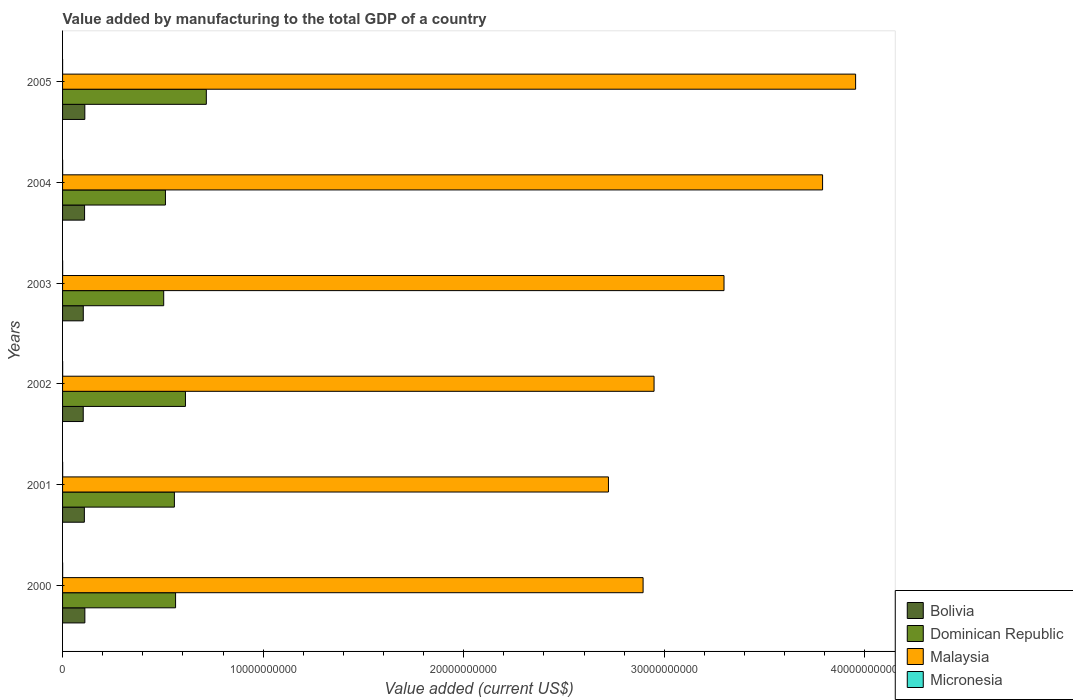How many different coloured bars are there?
Your answer should be compact. 4. Are the number of bars per tick equal to the number of legend labels?
Ensure brevity in your answer.  Yes. Are the number of bars on each tick of the Y-axis equal?
Offer a terse response. Yes. How many bars are there on the 6th tick from the top?
Your answer should be compact. 4. How many bars are there on the 1st tick from the bottom?
Your answer should be compact. 4. What is the value added by manufacturing to the total GDP in Micronesia in 2001?
Make the answer very short. 4.61e+06. Across all years, what is the maximum value added by manufacturing to the total GDP in Bolivia?
Provide a succinct answer. 1.11e+09. Across all years, what is the minimum value added by manufacturing to the total GDP in Bolivia?
Your answer should be compact. 1.03e+09. In which year was the value added by manufacturing to the total GDP in Micronesia maximum?
Provide a short and direct response. 2001. In which year was the value added by manufacturing to the total GDP in Bolivia minimum?
Provide a short and direct response. 2002. What is the total value added by manufacturing to the total GDP in Bolivia in the graph?
Your response must be concise. 6.47e+09. What is the difference between the value added by manufacturing to the total GDP in Malaysia in 2001 and that in 2002?
Offer a terse response. -2.27e+09. What is the difference between the value added by manufacturing to the total GDP in Bolivia in 2003 and the value added by manufacturing to the total GDP in Dominican Republic in 2002?
Your answer should be very brief. -5.09e+09. What is the average value added by manufacturing to the total GDP in Micronesia per year?
Offer a terse response. 3.63e+06. In the year 2003, what is the difference between the value added by manufacturing to the total GDP in Bolivia and value added by manufacturing to the total GDP in Dominican Republic?
Make the answer very short. -4.01e+09. In how many years, is the value added by manufacturing to the total GDP in Micronesia greater than 22000000000 US$?
Keep it short and to the point. 0. What is the ratio of the value added by manufacturing to the total GDP in Dominican Republic in 2002 to that in 2003?
Ensure brevity in your answer.  1.22. Is the difference between the value added by manufacturing to the total GDP in Bolivia in 2000 and 2004 greater than the difference between the value added by manufacturing to the total GDP in Dominican Republic in 2000 and 2004?
Your answer should be compact. No. What is the difference between the highest and the second highest value added by manufacturing to the total GDP in Micronesia?
Your response must be concise. 2.03e+05. What is the difference between the highest and the lowest value added by manufacturing to the total GDP in Dominican Republic?
Your answer should be compact. 2.13e+09. Is the sum of the value added by manufacturing to the total GDP in Bolivia in 2003 and 2005 greater than the maximum value added by manufacturing to the total GDP in Micronesia across all years?
Provide a short and direct response. Yes. What does the 1st bar from the top in 2002 represents?
Your response must be concise. Micronesia. What does the 2nd bar from the bottom in 2004 represents?
Ensure brevity in your answer.  Dominican Republic. Is it the case that in every year, the sum of the value added by manufacturing to the total GDP in Bolivia and value added by manufacturing to the total GDP in Micronesia is greater than the value added by manufacturing to the total GDP in Malaysia?
Ensure brevity in your answer.  No. How many bars are there?
Provide a succinct answer. 24. Are all the bars in the graph horizontal?
Offer a terse response. Yes. Are the values on the major ticks of X-axis written in scientific E-notation?
Ensure brevity in your answer.  No. Where does the legend appear in the graph?
Your answer should be compact. Bottom right. How many legend labels are there?
Make the answer very short. 4. What is the title of the graph?
Provide a succinct answer. Value added by manufacturing to the total GDP of a country. Does "Andorra" appear as one of the legend labels in the graph?
Provide a succinct answer. No. What is the label or title of the X-axis?
Give a very brief answer. Value added (current US$). What is the Value added (current US$) of Bolivia in 2000?
Provide a short and direct response. 1.11e+09. What is the Value added (current US$) in Dominican Republic in 2000?
Your answer should be very brief. 5.63e+09. What is the Value added (current US$) of Malaysia in 2000?
Your answer should be compact. 2.89e+1. What is the Value added (current US$) of Micronesia in 2000?
Your answer should be compact. 3.88e+06. What is the Value added (current US$) of Bolivia in 2001?
Make the answer very short. 1.09e+09. What is the Value added (current US$) in Dominican Republic in 2001?
Your response must be concise. 5.58e+09. What is the Value added (current US$) of Malaysia in 2001?
Offer a terse response. 2.72e+1. What is the Value added (current US$) in Micronesia in 2001?
Make the answer very short. 4.61e+06. What is the Value added (current US$) of Bolivia in 2002?
Give a very brief answer. 1.03e+09. What is the Value added (current US$) in Dominican Republic in 2002?
Offer a terse response. 6.13e+09. What is the Value added (current US$) in Malaysia in 2002?
Your answer should be very brief. 2.95e+1. What is the Value added (current US$) in Micronesia in 2002?
Your response must be concise. 4.41e+06. What is the Value added (current US$) of Bolivia in 2003?
Make the answer very short. 1.03e+09. What is the Value added (current US$) in Dominican Republic in 2003?
Offer a terse response. 5.04e+09. What is the Value added (current US$) of Malaysia in 2003?
Give a very brief answer. 3.30e+1. What is the Value added (current US$) of Micronesia in 2003?
Offer a terse response. 4.08e+06. What is the Value added (current US$) of Bolivia in 2004?
Offer a terse response. 1.10e+09. What is the Value added (current US$) of Dominican Republic in 2004?
Your response must be concise. 5.13e+09. What is the Value added (current US$) of Malaysia in 2004?
Provide a short and direct response. 3.79e+1. What is the Value added (current US$) in Micronesia in 2004?
Your answer should be compact. 3.40e+06. What is the Value added (current US$) in Bolivia in 2005?
Give a very brief answer. 1.11e+09. What is the Value added (current US$) of Dominican Republic in 2005?
Offer a very short reply. 7.17e+09. What is the Value added (current US$) in Malaysia in 2005?
Your answer should be very brief. 3.95e+1. What is the Value added (current US$) of Micronesia in 2005?
Provide a short and direct response. 1.40e+06. Across all years, what is the maximum Value added (current US$) of Bolivia?
Offer a terse response. 1.11e+09. Across all years, what is the maximum Value added (current US$) of Dominican Republic?
Provide a short and direct response. 7.17e+09. Across all years, what is the maximum Value added (current US$) of Malaysia?
Provide a succinct answer. 3.95e+1. Across all years, what is the maximum Value added (current US$) in Micronesia?
Make the answer very short. 4.61e+06. Across all years, what is the minimum Value added (current US$) in Bolivia?
Your response must be concise. 1.03e+09. Across all years, what is the minimum Value added (current US$) in Dominican Republic?
Offer a terse response. 5.04e+09. Across all years, what is the minimum Value added (current US$) of Malaysia?
Offer a terse response. 2.72e+1. Across all years, what is the minimum Value added (current US$) in Micronesia?
Make the answer very short. 1.40e+06. What is the total Value added (current US$) of Bolivia in the graph?
Offer a terse response. 6.47e+09. What is the total Value added (current US$) in Dominican Republic in the graph?
Your answer should be compact. 3.47e+1. What is the total Value added (current US$) in Malaysia in the graph?
Your answer should be compact. 1.96e+11. What is the total Value added (current US$) in Micronesia in the graph?
Provide a short and direct response. 2.18e+07. What is the difference between the Value added (current US$) of Bolivia in 2000 and that in 2001?
Offer a terse response. 2.55e+07. What is the difference between the Value added (current US$) of Dominican Republic in 2000 and that in 2001?
Provide a short and direct response. 5.89e+07. What is the difference between the Value added (current US$) in Malaysia in 2000 and that in 2001?
Offer a very short reply. 1.73e+09. What is the difference between the Value added (current US$) in Micronesia in 2000 and that in 2001?
Your response must be concise. -7.32e+05. What is the difference between the Value added (current US$) in Bolivia in 2000 and that in 2002?
Your answer should be very brief. 8.15e+07. What is the difference between the Value added (current US$) of Dominican Republic in 2000 and that in 2002?
Your response must be concise. -4.93e+08. What is the difference between the Value added (current US$) in Malaysia in 2000 and that in 2002?
Offer a very short reply. -5.47e+08. What is the difference between the Value added (current US$) in Micronesia in 2000 and that in 2002?
Offer a very short reply. -5.28e+05. What is the difference between the Value added (current US$) in Bolivia in 2000 and that in 2003?
Make the answer very short. 7.87e+07. What is the difference between the Value added (current US$) of Dominican Republic in 2000 and that in 2003?
Provide a short and direct response. 5.92e+08. What is the difference between the Value added (current US$) in Malaysia in 2000 and that in 2003?
Give a very brief answer. -4.04e+09. What is the difference between the Value added (current US$) in Micronesia in 2000 and that in 2003?
Offer a very short reply. -2.00e+05. What is the difference between the Value added (current US$) of Bolivia in 2000 and that in 2004?
Offer a very short reply. 1.46e+07. What is the difference between the Value added (current US$) of Dominican Republic in 2000 and that in 2004?
Ensure brevity in your answer.  5.06e+08. What is the difference between the Value added (current US$) of Malaysia in 2000 and that in 2004?
Your response must be concise. -8.95e+09. What is the difference between the Value added (current US$) of Micronesia in 2000 and that in 2004?
Offer a terse response. 4.79e+05. What is the difference between the Value added (current US$) in Bolivia in 2000 and that in 2005?
Ensure brevity in your answer.  1.71e+06. What is the difference between the Value added (current US$) of Dominican Republic in 2000 and that in 2005?
Your response must be concise. -1.53e+09. What is the difference between the Value added (current US$) of Malaysia in 2000 and that in 2005?
Your answer should be compact. -1.06e+1. What is the difference between the Value added (current US$) of Micronesia in 2000 and that in 2005?
Keep it short and to the point. 2.48e+06. What is the difference between the Value added (current US$) in Bolivia in 2001 and that in 2002?
Your response must be concise. 5.60e+07. What is the difference between the Value added (current US$) of Dominican Republic in 2001 and that in 2002?
Keep it short and to the point. -5.52e+08. What is the difference between the Value added (current US$) of Malaysia in 2001 and that in 2002?
Keep it short and to the point. -2.27e+09. What is the difference between the Value added (current US$) in Micronesia in 2001 and that in 2002?
Ensure brevity in your answer.  2.03e+05. What is the difference between the Value added (current US$) in Bolivia in 2001 and that in 2003?
Give a very brief answer. 5.32e+07. What is the difference between the Value added (current US$) in Dominican Republic in 2001 and that in 2003?
Provide a short and direct response. 5.33e+08. What is the difference between the Value added (current US$) of Malaysia in 2001 and that in 2003?
Give a very brief answer. -5.76e+09. What is the difference between the Value added (current US$) in Micronesia in 2001 and that in 2003?
Your answer should be compact. 5.32e+05. What is the difference between the Value added (current US$) in Bolivia in 2001 and that in 2004?
Give a very brief answer. -1.09e+07. What is the difference between the Value added (current US$) of Dominican Republic in 2001 and that in 2004?
Your answer should be compact. 4.47e+08. What is the difference between the Value added (current US$) of Malaysia in 2001 and that in 2004?
Offer a terse response. -1.07e+1. What is the difference between the Value added (current US$) in Micronesia in 2001 and that in 2004?
Your answer should be very brief. 1.21e+06. What is the difference between the Value added (current US$) of Bolivia in 2001 and that in 2005?
Your response must be concise. -2.38e+07. What is the difference between the Value added (current US$) in Dominican Republic in 2001 and that in 2005?
Provide a succinct answer. -1.59e+09. What is the difference between the Value added (current US$) in Malaysia in 2001 and that in 2005?
Provide a short and direct response. -1.23e+1. What is the difference between the Value added (current US$) of Micronesia in 2001 and that in 2005?
Make the answer very short. 3.21e+06. What is the difference between the Value added (current US$) of Bolivia in 2002 and that in 2003?
Your response must be concise. -2.77e+06. What is the difference between the Value added (current US$) in Dominican Republic in 2002 and that in 2003?
Provide a succinct answer. 1.08e+09. What is the difference between the Value added (current US$) of Malaysia in 2002 and that in 2003?
Provide a succinct answer. -3.49e+09. What is the difference between the Value added (current US$) in Micronesia in 2002 and that in 2003?
Your answer should be very brief. 3.28e+05. What is the difference between the Value added (current US$) of Bolivia in 2002 and that in 2004?
Provide a short and direct response. -6.68e+07. What is the difference between the Value added (current US$) of Dominican Republic in 2002 and that in 2004?
Give a very brief answer. 9.99e+08. What is the difference between the Value added (current US$) of Malaysia in 2002 and that in 2004?
Offer a very short reply. -8.40e+09. What is the difference between the Value added (current US$) in Micronesia in 2002 and that in 2004?
Offer a very short reply. 1.01e+06. What is the difference between the Value added (current US$) of Bolivia in 2002 and that in 2005?
Give a very brief answer. -7.98e+07. What is the difference between the Value added (current US$) in Dominican Republic in 2002 and that in 2005?
Provide a short and direct response. -1.04e+09. What is the difference between the Value added (current US$) of Malaysia in 2002 and that in 2005?
Your response must be concise. -1.00e+1. What is the difference between the Value added (current US$) of Micronesia in 2002 and that in 2005?
Provide a short and direct response. 3.01e+06. What is the difference between the Value added (current US$) of Bolivia in 2003 and that in 2004?
Your response must be concise. -6.40e+07. What is the difference between the Value added (current US$) in Dominican Republic in 2003 and that in 2004?
Offer a very short reply. -8.61e+07. What is the difference between the Value added (current US$) of Malaysia in 2003 and that in 2004?
Make the answer very short. -4.91e+09. What is the difference between the Value added (current US$) of Micronesia in 2003 and that in 2004?
Offer a terse response. 6.79e+05. What is the difference between the Value added (current US$) in Bolivia in 2003 and that in 2005?
Ensure brevity in your answer.  -7.70e+07. What is the difference between the Value added (current US$) of Dominican Republic in 2003 and that in 2005?
Keep it short and to the point. -2.13e+09. What is the difference between the Value added (current US$) in Malaysia in 2003 and that in 2005?
Ensure brevity in your answer.  -6.56e+09. What is the difference between the Value added (current US$) in Micronesia in 2003 and that in 2005?
Ensure brevity in your answer.  2.68e+06. What is the difference between the Value added (current US$) of Bolivia in 2004 and that in 2005?
Provide a succinct answer. -1.29e+07. What is the difference between the Value added (current US$) in Dominican Republic in 2004 and that in 2005?
Your response must be concise. -2.04e+09. What is the difference between the Value added (current US$) in Malaysia in 2004 and that in 2005?
Make the answer very short. -1.65e+09. What is the difference between the Value added (current US$) of Bolivia in 2000 and the Value added (current US$) of Dominican Republic in 2001?
Offer a very short reply. -4.46e+09. What is the difference between the Value added (current US$) in Bolivia in 2000 and the Value added (current US$) in Malaysia in 2001?
Ensure brevity in your answer.  -2.61e+1. What is the difference between the Value added (current US$) of Bolivia in 2000 and the Value added (current US$) of Micronesia in 2001?
Your response must be concise. 1.11e+09. What is the difference between the Value added (current US$) in Dominican Republic in 2000 and the Value added (current US$) in Malaysia in 2001?
Provide a short and direct response. -2.16e+1. What is the difference between the Value added (current US$) of Dominican Republic in 2000 and the Value added (current US$) of Micronesia in 2001?
Offer a terse response. 5.63e+09. What is the difference between the Value added (current US$) of Malaysia in 2000 and the Value added (current US$) of Micronesia in 2001?
Offer a terse response. 2.89e+1. What is the difference between the Value added (current US$) in Bolivia in 2000 and the Value added (current US$) in Dominican Republic in 2002?
Make the answer very short. -5.02e+09. What is the difference between the Value added (current US$) in Bolivia in 2000 and the Value added (current US$) in Malaysia in 2002?
Your answer should be compact. -2.84e+1. What is the difference between the Value added (current US$) in Bolivia in 2000 and the Value added (current US$) in Micronesia in 2002?
Offer a terse response. 1.11e+09. What is the difference between the Value added (current US$) of Dominican Republic in 2000 and the Value added (current US$) of Malaysia in 2002?
Your answer should be very brief. -2.39e+1. What is the difference between the Value added (current US$) in Dominican Republic in 2000 and the Value added (current US$) in Micronesia in 2002?
Make the answer very short. 5.63e+09. What is the difference between the Value added (current US$) in Malaysia in 2000 and the Value added (current US$) in Micronesia in 2002?
Provide a succinct answer. 2.89e+1. What is the difference between the Value added (current US$) of Bolivia in 2000 and the Value added (current US$) of Dominican Republic in 2003?
Offer a very short reply. -3.93e+09. What is the difference between the Value added (current US$) of Bolivia in 2000 and the Value added (current US$) of Malaysia in 2003?
Your answer should be compact. -3.19e+1. What is the difference between the Value added (current US$) of Bolivia in 2000 and the Value added (current US$) of Micronesia in 2003?
Your response must be concise. 1.11e+09. What is the difference between the Value added (current US$) in Dominican Republic in 2000 and the Value added (current US$) in Malaysia in 2003?
Keep it short and to the point. -2.73e+1. What is the difference between the Value added (current US$) in Dominican Republic in 2000 and the Value added (current US$) in Micronesia in 2003?
Provide a succinct answer. 5.63e+09. What is the difference between the Value added (current US$) in Malaysia in 2000 and the Value added (current US$) in Micronesia in 2003?
Keep it short and to the point. 2.89e+1. What is the difference between the Value added (current US$) of Bolivia in 2000 and the Value added (current US$) of Dominican Republic in 2004?
Offer a terse response. -4.02e+09. What is the difference between the Value added (current US$) in Bolivia in 2000 and the Value added (current US$) in Malaysia in 2004?
Provide a succinct answer. -3.68e+1. What is the difference between the Value added (current US$) of Bolivia in 2000 and the Value added (current US$) of Micronesia in 2004?
Provide a short and direct response. 1.11e+09. What is the difference between the Value added (current US$) in Dominican Republic in 2000 and the Value added (current US$) in Malaysia in 2004?
Ensure brevity in your answer.  -3.23e+1. What is the difference between the Value added (current US$) of Dominican Republic in 2000 and the Value added (current US$) of Micronesia in 2004?
Ensure brevity in your answer.  5.63e+09. What is the difference between the Value added (current US$) of Malaysia in 2000 and the Value added (current US$) of Micronesia in 2004?
Keep it short and to the point. 2.89e+1. What is the difference between the Value added (current US$) of Bolivia in 2000 and the Value added (current US$) of Dominican Republic in 2005?
Ensure brevity in your answer.  -6.06e+09. What is the difference between the Value added (current US$) in Bolivia in 2000 and the Value added (current US$) in Malaysia in 2005?
Give a very brief answer. -3.84e+1. What is the difference between the Value added (current US$) of Bolivia in 2000 and the Value added (current US$) of Micronesia in 2005?
Your response must be concise. 1.11e+09. What is the difference between the Value added (current US$) in Dominican Republic in 2000 and the Value added (current US$) in Malaysia in 2005?
Keep it short and to the point. -3.39e+1. What is the difference between the Value added (current US$) in Dominican Republic in 2000 and the Value added (current US$) in Micronesia in 2005?
Offer a terse response. 5.63e+09. What is the difference between the Value added (current US$) in Malaysia in 2000 and the Value added (current US$) in Micronesia in 2005?
Give a very brief answer. 2.89e+1. What is the difference between the Value added (current US$) in Bolivia in 2001 and the Value added (current US$) in Dominican Republic in 2002?
Offer a terse response. -5.04e+09. What is the difference between the Value added (current US$) in Bolivia in 2001 and the Value added (current US$) in Malaysia in 2002?
Keep it short and to the point. -2.84e+1. What is the difference between the Value added (current US$) of Bolivia in 2001 and the Value added (current US$) of Micronesia in 2002?
Provide a succinct answer. 1.08e+09. What is the difference between the Value added (current US$) in Dominican Republic in 2001 and the Value added (current US$) in Malaysia in 2002?
Offer a very short reply. -2.39e+1. What is the difference between the Value added (current US$) of Dominican Republic in 2001 and the Value added (current US$) of Micronesia in 2002?
Provide a short and direct response. 5.57e+09. What is the difference between the Value added (current US$) in Malaysia in 2001 and the Value added (current US$) in Micronesia in 2002?
Provide a succinct answer. 2.72e+1. What is the difference between the Value added (current US$) in Bolivia in 2001 and the Value added (current US$) in Dominican Republic in 2003?
Offer a terse response. -3.96e+09. What is the difference between the Value added (current US$) of Bolivia in 2001 and the Value added (current US$) of Malaysia in 2003?
Make the answer very short. -3.19e+1. What is the difference between the Value added (current US$) of Bolivia in 2001 and the Value added (current US$) of Micronesia in 2003?
Provide a short and direct response. 1.08e+09. What is the difference between the Value added (current US$) in Dominican Republic in 2001 and the Value added (current US$) in Malaysia in 2003?
Ensure brevity in your answer.  -2.74e+1. What is the difference between the Value added (current US$) of Dominican Republic in 2001 and the Value added (current US$) of Micronesia in 2003?
Provide a short and direct response. 5.57e+09. What is the difference between the Value added (current US$) in Malaysia in 2001 and the Value added (current US$) in Micronesia in 2003?
Provide a succinct answer. 2.72e+1. What is the difference between the Value added (current US$) of Bolivia in 2001 and the Value added (current US$) of Dominican Republic in 2004?
Offer a very short reply. -4.04e+09. What is the difference between the Value added (current US$) of Bolivia in 2001 and the Value added (current US$) of Malaysia in 2004?
Give a very brief answer. -3.68e+1. What is the difference between the Value added (current US$) of Bolivia in 2001 and the Value added (current US$) of Micronesia in 2004?
Offer a terse response. 1.08e+09. What is the difference between the Value added (current US$) in Dominican Republic in 2001 and the Value added (current US$) in Malaysia in 2004?
Your answer should be compact. -3.23e+1. What is the difference between the Value added (current US$) of Dominican Republic in 2001 and the Value added (current US$) of Micronesia in 2004?
Ensure brevity in your answer.  5.57e+09. What is the difference between the Value added (current US$) in Malaysia in 2001 and the Value added (current US$) in Micronesia in 2004?
Provide a succinct answer. 2.72e+1. What is the difference between the Value added (current US$) of Bolivia in 2001 and the Value added (current US$) of Dominican Republic in 2005?
Make the answer very short. -6.08e+09. What is the difference between the Value added (current US$) in Bolivia in 2001 and the Value added (current US$) in Malaysia in 2005?
Your answer should be very brief. -3.85e+1. What is the difference between the Value added (current US$) of Bolivia in 2001 and the Value added (current US$) of Micronesia in 2005?
Offer a terse response. 1.09e+09. What is the difference between the Value added (current US$) in Dominican Republic in 2001 and the Value added (current US$) in Malaysia in 2005?
Ensure brevity in your answer.  -3.40e+1. What is the difference between the Value added (current US$) of Dominican Republic in 2001 and the Value added (current US$) of Micronesia in 2005?
Your response must be concise. 5.57e+09. What is the difference between the Value added (current US$) in Malaysia in 2001 and the Value added (current US$) in Micronesia in 2005?
Provide a short and direct response. 2.72e+1. What is the difference between the Value added (current US$) in Bolivia in 2002 and the Value added (current US$) in Dominican Republic in 2003?
Provide a short and direct response. -4.01e+09. What is the difference between the Value added (current US$) in Bolivia in 2002 and the Value added (current US$) in Malaysia in 2003?
Keep it short and to the point. -3.20e+1. What is the difference between the Value added (current US$) in Bolivia in 2002 and the Value added (current US$) in Micronesia in 2003?
Provide a short and direct response. 1.03e+09. What is the difference between the Value added (current US$) in Dominican Republic in 2002 and the Value added (current US$) in Malaysia in 2003?
Keep it short and to the point. -2.69e+1. What is the difference between the Value added (current US$) in Dominican Republic in 2002 and the Value added (current US$) in Micronesia in 2003?
Your answer should be compact. 6.12e+09. What is the difference between the Value added (current US$) of Malaysia in 2002 and the Value added (current US$) of Micronesia in 2003?
Keep it short and to the point. 2.95e+1. What is the difference between the Value added (current US$) of Bolivia in 2002 and the Value added (current US$) of Dominican Republic in 2004?
Give a very brief answer. -4.10e+09. What is the difference between the Value added (current US$) of Bolivia in 2002 and the Value added (current US$) of Malaysia in 2004?
Give a very brief answer. -3.69e+1. What is the difference between the Value added (current US$) in Bolivia in 2002 and the Value added (current US$) in Micronesia in 2004?
Your answer should be very brief. 1.03e+09. What is the difference between the Value added (current US$) in Dominican Republic in 2002 and the Value added (current US$) in Malaysia in 2004?
Offer a very short reply. -3.18e+1. What is the difference between the Value added (current US$) in Dominican Republic in 2002 and the Value added (current US$) in Micronesia in 2004?
Your response must be concise. 6.12e+09. What is the difference between the Value added (current US$) in Malaysia in 2002 and the Value added (current US$) in Micronesia in 2004?
Offer a very short reply. 2.95e+1. What is the difference between the Value added (current US$) of Bolivia in 2002 and the Value added (current US$) of Dominican Republic in 2005?
Provide a short and direct response. -6.14e+09. What is the difference between the Value added (current US$) of Bolivia in 2002 and the Value added (current US$) of Malaysia in 2005?
Give a very brief answer. -3.85e+1. What is the difference between the Value added (current US$) in Bolivia in 2002 and the Value added (current US$) in Micronesia in 2005?
Ensure brevity in your answer.  1.03e+09. What is the difference between the Value added (current US$) in Dominican Republic in 2002 and the Value added (current US$) in Malaysia in 2005?
Your response must be concise. -3.34e+1. What is the difference between the Value added (current US$) of Dominican Republic in 2002 and the Value added (current US$) of Micronesia in 2005?
Provide a short and direct response. 6.13e+09. What is the difference between the Value added (current US$) in Malaysia in 2002 and the Value added (current US$) in Micronesia in 2005?
Offer a terse response. 2.95e+1. What is the difference between the Value added (current US$) of Bolivia in 2003 and the Value added (current US$) of Dominican Republic in 2004?
Your answer should be very brief. -4.10e+09. What is the difference between the Value added (current US$) of Bolivia in 2003 and the Value added (current US$) of Malaysia in 2004?
Ensure brevity in your answer.  -3.69e+1. What is the difference between the Value added (current US$) in Bolivia in 2003 and the Value added (current US$) in Micronesia in 2004?
Provide a succinct answer. 1.03e+09. What is the difference between the Value added (current US$) in Dominican Republic in 2003 and the Value added (current US$) in Malaysia in 2004?
Your answer should be compact. -3.29e+1. What is the difference between the Value added (current US$) in Dominican Republic in 2003 and the Value added (current US$) in Micronesia in 2004?
Offer a very short reply. 5.04e+09. What is the difference between the Value added (current US$) of Malaysia in 2003 and the Value added (current US$) of Micronesia in 2004?
Give a very brief answer. 3.30e+1. What is the difference between the Value added (current US$) in Bolivia in 2003 and the Value added (current US$) in Dominican Republic in 2005?
Keep it short and to the point. -6.14e+09. What is the difference between the Value added (current US$) of Bolivia in 2003 and the Value added (current US$) of Malaysia in 2005?
Your answer should be very brief. -3.85e+1. What is the difference between the Value added (current US$) of Bolivia in 2003 and the Value added (current US$) of Micronesia in 2005?
Offer a very short reply. 1.03e+09. What is the difference between the Value added (current US$) in Dominican Republic in 2003 and the Value added (current US$) in Malaysia in 2005?
Offer a very short reply. -3.45e+1. What is the difference between the Value added (current US$) of Dominican Republic in 2003 and the Value added (current US$) of Micronesia in 2005?
Your answer should be very brief. 5.04e+09. What is the difference between the Value added (current US$) of Malaysia in 2003 and the Value added (current US$) of Micronesia in 2005?
Make the answer very short. 3.30e+1. What is the difference between the Value added (current US$) in Bolivia in 2004 and the Value added (current US$) in Dominican Republic in 2005?
Make the answer very short. -6.07e+09. What is the difference between the Value added (current US$) in Bolivia in 2004 and the Value added (current US$) in Malaysia in 2005?
Ensure brevity in your answer.  -3.84e+1. What is the difference between the Value added (current US$) of Bolivia in 2004 and the Value added (current US$) of Micronesia in 2005?
Your answer should be compact. 1.10e+09. What is the difference between the Value added (current US$) in Dominican Republic in 2004 and the Value added (current US$) in Malaysia in 2005?
Your answer should be very brief. -3.44e+1. What is the difference between the Value added (current US$) of Dominican Republic in 2004 and the Value added (current US$) of Micronesia in 2005?
Give a very brief answer. 5.13e+09. What is the difference between the Value added (current US$) of Malaysia in 2004 and the Value added (current US$) of Micronesia in 2005?
Provide a short and direct response. 3.79e+1. What is the average Value added (current US$) of Bolivia per year?
Keep it short and to the point. 1.08e+09. What is the average Value added (current US$) of Dominican Republic per year?
Provide a succinct answer. 5.78e+09. What is the average Value added (current US$) in Malaysia per year?
Give a very brief answer. 3.27e+1. What is the average Value added (current US$) in Micronesia per year?
Provide a succinct answer. 3.63e+06. In the year 2000, what is the difference between the Value added (current US$) of Bolivia and Value added (current US$) of Dominican Republic?
Provide a succinct answer. -4.52e+09. In the year 2000, what is the difference between the Value added (current US$) of Bolivia and Value added (current US$) of Malaysia?
Your answer should be compact. -2.78e+1. In the year 2000, what is the difference between the Value added (current US$) of Bolivia and Value added (current US$) of Micronesia?
Your response must be concise. 1.11e+09. In the year 2000, what is the difference between the Value added (current US$) of Dominican Republic and Value added (current US$) of Malaysia?
Offer a very short reply. -2.33e+1. In the year 2000, what is the difference between the Value added (current US$) in Dominican Republic and Value added (current US$) in Micronesia?
Ensure brevity in your answer.  5.63e+09. In the year 2000, what is the difference between the Value added (current US$) of Malaysia and Value added (current US$) of Micronesia?
Keep it short and to the point. 2.89e+1. In the year 2001, what is the difference between the Value added (current US$) of Bolivia and Value added (current US$) of Dominican Republic?
Make the answer very short. -4.49e+09. In the year 2001, what is the difference between the Value added (current US$) of Bolivia and Value added (current US$) of Malaysia?
Give a very brief answer. -2.61e+1. In the year 2001, what is the difference between the Value added (current US$) in Bolivia and Value added (current US$) in Micronesia?
Provide a succinct answer. 1.08e+09. In the year 2001, what is the difference between the Value added (current US$) of Dominican Republic and Value added (current US$) of Malaysia?
Give a very brief answer. -2.16e+1. In the year 2001, what is the difference between the Value added (current US$) of Dominican Republic and Value added (current US$) of Micronesia?
Offer a terse response. 5.57e+09. In the year 2001, what is the difference between the Value added (current US$) in Malaysia and Value added (current US$) in Micronesia?
Ensure brevity in your answer.  2.72e+1. In the year 2002, what is the difference between the Value added (current US$) of Bolivia and Value added (current US$) of Dominican Republic?
Your answer should be compact. -5.10e+09. In the year 2002, what is the difference between the Value added (current US$) of Bolivia and Value added (current US$) of Malaysia?
Your response must be concise. -2.85e+1. In the year 2002, what is the difference between the Value added (current US$) in Bolivia and Value added (current US$) in Micronesia?
Give a very brief answer. 1.03e+09. In the year 2002, what is the difference between the Value added (current US$) in Dominican Republic and Value added (current US$) in Malaysia?
Your answer should be very brief. -2.34e+1. In the year 2002, what is the difference between the Value added (current US$) in Dominican Republic and Value added (current US$) in Micronesia?
Your response must be concise. 6.12e+09. In the year 2002, what is the difference between the Value added (current US$) in Malaysia and Value added (current US$) in Micronesia?
Provide a short and direct response. 2.95e+1. In the year 2003, what is the difference between the Value added (current US$) in Bolivia and Value added (current US$) in Dominican Republic?
Provide a succinct answer. -4.01e+09. In the year 2003, what is the difference between the Value added (current US$) of Bolivia and Value added (current US$) of Malaysia?
Offer a terse response. -3.19e+1. In the year 2003, what is the difference between the Value added (current US$) in Bolivia and Value added (current US$) in Micronesia?
Provide a short and direct response. 1.03e+09. In the year 2003, what is the difference between the Value added (current US$) in Dominican Republic and Value added (current US$) in Malaysia?
Provide a short and direct response. -2.79e+1. In the year 2003, what is the difference between the Value added (current US$) in Dominican Republic and Value added (current US$) in Micronesia?
Offer a terse response. 5.04e+09. In the year 2003, what is the difference between the Value added (current US$) of Malaysia and Value added (current US$) of Micronesia?
Offer a very short reply. 3.30e+1. In the year 2004, what is the difference between the Value added (current US$) of Bolivia and Value added (current US$) of Dominican Republic?
Ensure brevity in your answer.  -4.03e+09. In the year 2004, what is the difference between the Value added (current US$) of Bolivia and Value added (current US$) of Malaysia?
Offer a terse response. -3.68e+1. In the year 2004, what is the difference between the Value added (current US$) in Bolivia and Value added (current US$) in Micronesia?
Offer a very short reply. 1.09e+09. In the year 2004, what is the difference between the Value added (current US$) of Dominican Republic and Value added (current US$) of Malaysia?
Provide a succinct answer. -3.28e+1. In the year 2004, what is the difference between the Value added (current US$) of Dominican Republic and Value added (current US$) of Micronesia?
Keep it short and to the point. 5.13e+09. In the year 2004, what is the difference between the Value added (current US$) in Malaysia and Value added (current US$) in Micronesia?
Make the answer very short. 3.79e+1. In the year 2005, what is the difference between the Value added (current US$) in Bolivia and Value added (current US$) in Dominican Republic?
Offer a very short reply. -6.06e+09. In the year 2005, what is the difference between the Value added (current US$) in Bolivia and Value added (current US$) in Malaysia?
Make the answer very short. -3.84e+1. In the year 2005, what is the difference between the Value added (current US$) of Bolivia and Value added (current US$) of Micronesia?
Offer a terse response. 1.11e+09. In the year 2005, what is the difference between the Value added (current US$) of Dominican Republic and Value added (current US$) of Malaysia?
Give a very brief answer. -3.24e+1. In the year 2005, what is the difference between the Value added (current US$) of Dominican Republic and Value added (current US$) of Micronesia?
Give a very brief answer. 7.17e+09. In the year 2005, what is the difference between the Value added (current US$) in Malaysia and Value added (current US$) in Micronesia?
Provide a short and direct response. 3.95e+1. What is the ratio of the Value added (current US$) of Bolivia in 2000 to that in 2001?
Your answer should be very brief. 1.02. What is the ratio of the Value added (current US$) of Dominican Republic in 2000 to that in 2001?
Ensure brevity in your answer.  1.01. What is the ratio of the Value added (current US$) of Malaysia in 2000 to that in 2001?
Ensure brevity in your answer.  1.06. What is the ratio of the Value added (current US$) in Micronesia in 2000 to that in 2001?
Offer a terse response. 0.84. What is the ratio of the Value added (current US$) of Bolivia in 2000 to that in 2002?
Ensure brevity in your answer.  1.08. What is the ratio of the Value added (current US$) in Dominican Republic in 2000 to that in 2002?
Your answer should be very brief. 0.92. What is the ratio of the Value added (current US$) in Malaysia in 2000 to that in 2002?
Offer a very short reply. 0.98. What is the ratio of the Value added (current US$) of Micronesia in 2000 to that in 2002?
Your answer should be very brief. 0.88. What is the ratio of the Value added (current US$) in Bolivia in 2000 to that in 2003?
Provide a succinct answer. 1.08. What is the ratio of the Value added (current US$) in Dominican Republic in 2000 to that in 2003?
Make the answer very short. 1.12. What is the ratio of the Value added (current US$) of Malaysia in 2000 to that in 2003?
Your response must be concise. 0.88. What is the ratio of the Value added (current US$) of Micronesia in 2000 to that in 2003?
Keep it short and to the point. 0.95. What is the ratio of the Value added (current US$) in Bolivia in 2000 to that in 2004?
Your response must be concise. 1.01. What is the ratio of the Value added (current US$) in Dominican Republic in 2000 to that in 2004?
Your answer should be compact. 1.1. What is the ratio of the Value added (current US$) in Malaysia in 2000 to that in 2004?
Provide a short and direct response. 0.76. What is the ratio of the Value added (current US$) in Micronesia in 2000 to that in 2004?
Give a very brief answer. 1.14. What is the ratio of the Value added (current US$) of Bolivia in 2000 to that in 2005?
Make the answer very short. 1. What is the ratio of the Value added (current US$) of Dominican Republic in 2000 to that in 2005?
Make the answer very short. 0.79. What is the ratio of the Value added (current US$) of Malaysia in 2000 to that in 2005?
Give a very brief answer. 0.73. What is the ratio of the Value added (current US$) in Micronesia in 2000 to that in 2005?
Keep it short and to the point. 2.77. What is the ratio of the Value added (current US$) in Bolivia in 2001 to that in 2002?
Offer a terse response. 1.05. What is the ratio of the Value added (current US$) of Dominican Republic in 2001 to that in 2002?
Give a very brief answer. 0.91. What is the ratio of the Value added (current US$) in Malaysia in 2001 to that in 2002?
Offer a very short reply. 0.92. What is the ratio of the Value added (current US$) in Micronesia in 2001 to that in 2002?
Your answer should be very brief. 1.05. What is the ratio of the Value added (current US$) in Bolivia in 2001 to that in 2003?
Make the answer very short. 1.05. What is the ratio of the Value added (current US$) of Dominican Republic in 2001 to that in 2003?
Your response must be concise. 1.11. What is the ratio of the Value added (current US$) in Malaysia in 2001 to that in 2003?
Ensure brevity in your answer.  0.83. What is the ratio of the Value added (current US$) of Micronesia in 2001 to that in 2003?
Offer a very short reply. 1.13. What is the ratio of the Value added (current US$) in Dominican Republic in 2001 to that in 2004?
Provide a short and direct response. 1.09. What is the ratio of the Value added (current US$) of Malaysia in 2001 to that in 2004?
Provide a succinct answer. 0.72. What is the ratio of the Value added (current US$) in Micronesia in 2001 to that in 2004?
Keep it short and to the point. 1.36. What is the ratio of the Value added (current US$) of Bolivia in 2001 to that in 2005?
Your response must be concise. 0.98. What is the ratio of the Value added (current US$) in Dominican Republic in 2001 to that in 2005?
Make the answer very short. 0.78. What is the ratio of the Value added (current US$) of Malaysia in 2001 to that in 2005?
Offer a very short reply. 0.69. What is the ratio of the Value added (current US$) in Micronesia in 2001 to that in 2005?
Offer a terse response. 3.29. What is the ratio of the Value added (current US$) in Bolivia in 2002 to that in 2003?
Offer a very short reply. 1. What is the ratio of the Value added (current US$) of Dominican Republic in 2002 to that in 2003?
Ensure brevity in your answer.  1.22. What is the ratio of the Value added (current US$) of Malaysia in 2002 to that in 2003?
Provide a short and direct response. 0.89. What is the ratio of the Value added (current US$) in Micronesia in 2002 to that in 2003?
Ensure brevity in your answer.  1.08. What is the ratio of the Value added (current US$) in Bolivia in 2002 to that in 2004?
Make the answer very short. 0.94. What is the ratio of the Value added (current US$) in Dominican Republic in 2002 to that in 2004?
Your answer should be very brief. 1.19. What is the ratio of the Value added (current US$) of Malaysia in 2002 to that in 2004?
Your answer should be very brief. 0.78. What is the ratio of the Value added (current US$) of Micronesia in 2002 to that in 2004?
Your answer should be very brief. 1.3. What is the ratio of the Value added (current US$) of Bolivia in 2002 to that in 2005?
Make the answer very short. 0.93. What is the ratio of the Value added (current US$) in Dominican Republic in 2002 to that in 2005?
Offer a terse response. 0.85. What is the ratio of the Value added (current US$) of Malaysia in 2002 to that in 2005?
Offer a terse response. 0.75. What is the ratio of the Value added (current US$) of Micronesia in 2002 to that in 2005?
Provide a succinct answer. 3.15. What is the ratio of the Value added (current US$) of Bolivia in 2003 to that in 2004?
Make the answer very short. 0.94. What is the ratio of the Value added (current US$) of Dominican Republic in 2003 to that in 2004?
Your answer should be compact. 0.98. What is the ratio of the Value added (current US$) of Malaysia in 2003 to that in 2004?
Offer a very short reply. 0.87. What is the ratio of the Value added (current US$) in Micronesia in 2003 to that in 2004?
Keep it short and to the point. 1.2. What is the ratio of the Value added (current US$) of Bolivia in 2003 to that in 2005?
Provide a short and direct response. 0.93. What is the ratio of the Value added (current US$) of Dominican Republic in 2003 to that in 2005?
Your answer should be compact. 0.7. What is the ratio of the Value added (current US$) of Malaysia in 2003 to that in 2005?
Your answer should be very brief. 0.83. What is the ratio of the Value added (current US$) in Micronesia in 2003 to that in 2005?
Offer a terse response. 2.91. What is the ratio of the Value added (current US$) in Bolivia in 2004 to that in 2005?
Your answer should be compact. 0.99. What is the ratio of the Value added (current US$) in Dominican Republic in 2004 to that in 2005?
Offer a very short reply. 0.72. What is the ratio of the Value added (current US$) in Malaysia in 2004 to that in 2005?
Your answer should be compact. 0.96. What is the ratio of the Value added (current US$) in Micronesia in 2004 to that in 2005?
Your answer should be very brief. 2.43. What is the difference between the highest and the second highest Value added (current US$) of Bolivia?
Offer a very short reply. 1.71e+06. What is the difference between the highest and the second highest Value added (current US$) of Dominican Republic?
Offer a terse response. 1.04e+09. What is the difference between the highest and the second highest Value added (current US$) of Malaysia?
Provide a succinct answer. 1.65e+09. What is the difference between the highest and the second highest Value added (current US$) of Micronesia?
Ensure brevity in your answer.  2.03e+05. What is the difference between the highest and the lowest Value added (current US$) of Bolivia?
Provide a short and direct response. 8.15e+07. What is the difference between the highest and the lowest Value added (current US$) of Dominican Republic?
Provide a succinct answer. 2.13e+09. What is the difference between the highest and the lowest Value added (current US$) of Malaysia?
Your answer should be very brief. 1.23e+1. What is the difference between the highest and the lowest Value added (current US$) of Micronesia?
Provide a short and direct response. 3.21e+06. 